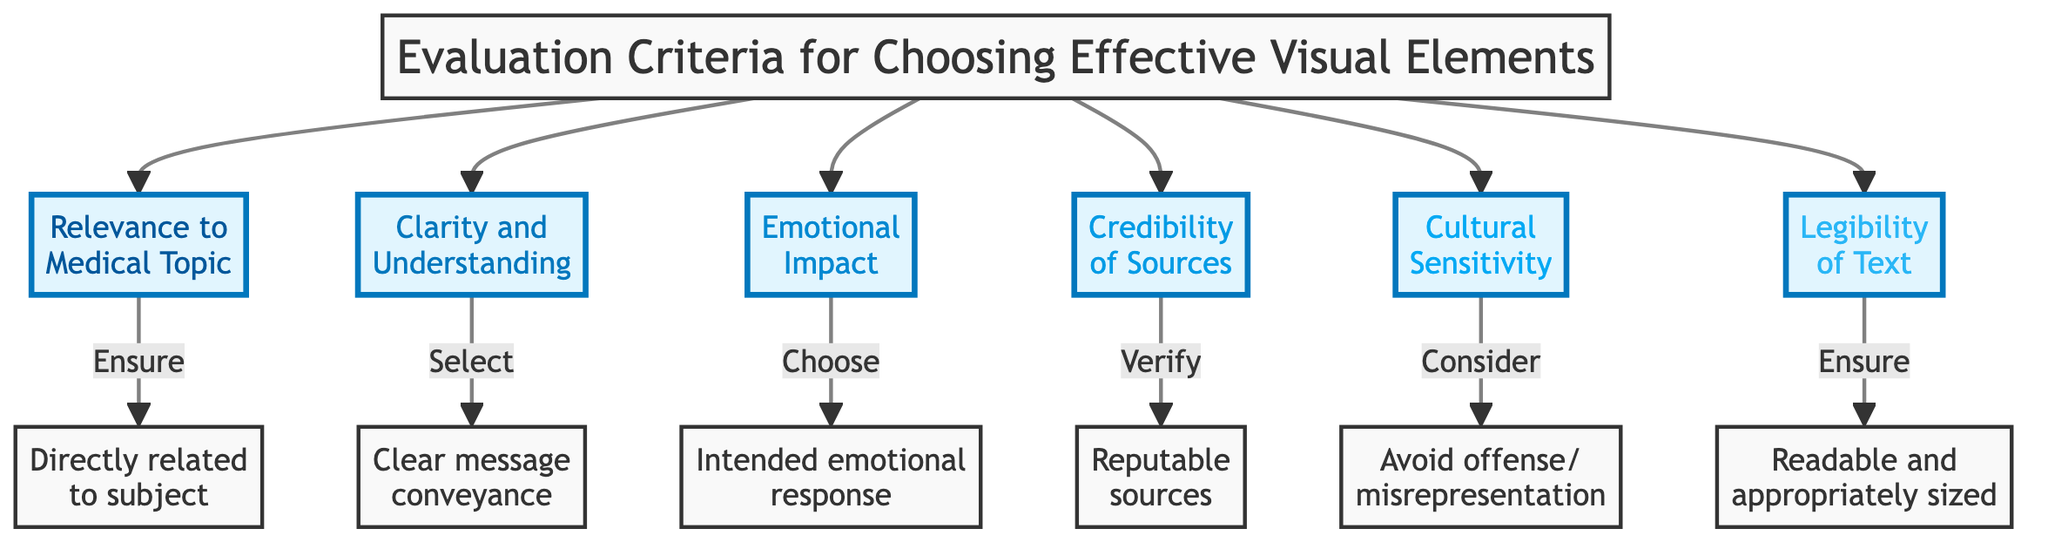What are the six evaluation criteria listed in the diagram? The diagram lists the following six criteria: Relevance to Medical Topic, Clarity and Understanding, Emotional Impact, Credibility of Sources, Cultural Sensitivity, and Legibility of Text.
Answer: Relevance to Medical Topic, Clarity and Understanding, Emotional Impact, Credibility of Sources, Cultural Sensitivity, Legibility of Text What is the main focus of the criteria labeled '3'? Criteria '3' is titled 'Emotional Impact', which emphasizes selecting visuals that elicit the desired emotional response from the audience.
Answer: Emotional Impact How many nodes represent evaluation criteria in the diagram? The diagram displays six nodes, each representing a different evaluation criterion for visual elements in medical narratives.
Answer: 6 What is the direct consequence of selecting images based on clarity and understanding? The clarity and understanding criterion leads to the selection of images that clearly convey the intended message without causing confusion.
Answer: Clear message conveyance Which criterion emphasizes the importance of reputable sources for visual content? The criterion titled 'Credibility of Sources' stresses the verification of visuals from reputable sources to enhance trust.
Answer: Credibility of Sources How does cultural sensitivity relate to the selection of visual elements? Cultural sensitivity involves considering cultural perceptions to prevent visuals from offending or misrepresenting the subject matter.
Answer: Avoid offense/misrepresentation What is the relationship between legibility of text and the effectiveness of visuals? The legibility of text criterion states that visuals must have readable and appropriately sized text to be effective in communicating the message.
Answer: Readable and appropriately sized What action should be taken regarding the relevance of visuals to the medical topic? The action prescribed for the 'Relevance to Medical Topic' criterion is to ensure that visuals directly relate to the medical subject being discussed.
Answer: Ensure directly related to subject How are emotions meant to be influenced by the visuals in the medical narratives? The criterion 'Emotional Impact' indicates that visuals should be chosen to evoke the intended emotional response from the audience through their design and content.
Answer: Intended emotional response 